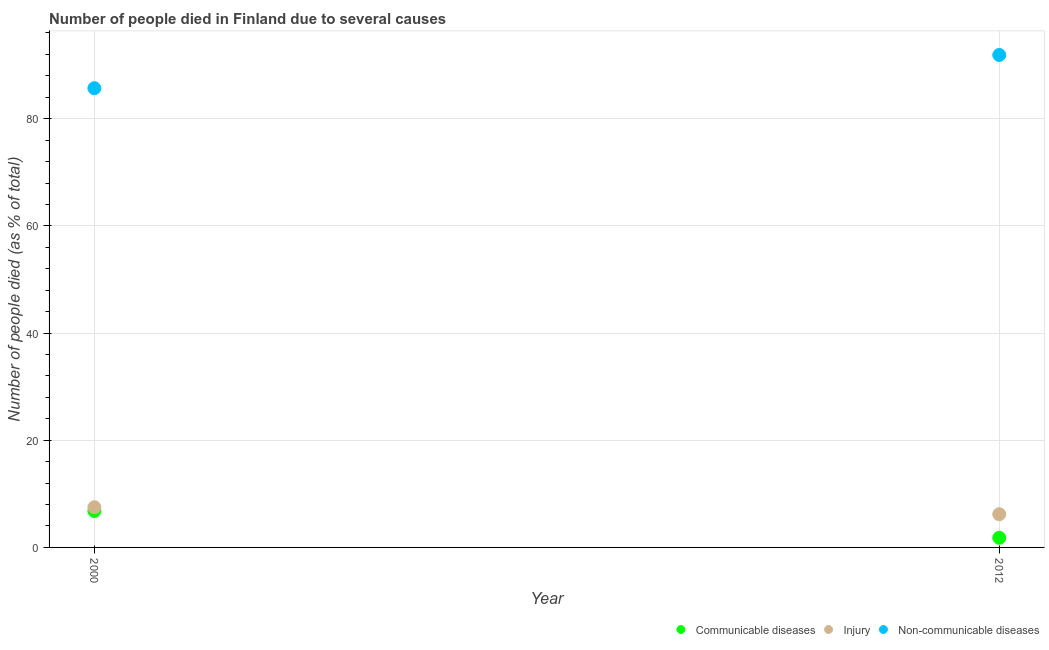How many different coloured dotlines are there?
Provide a short and direct response. 3. What is the number of people who dies of non-communicable diseases in 2000?
Provide a succinct answer. 85.7. Across all years, what is the maximum number of people who died of communicable diseases?
Your answer should be compact. 6.8. Across all years, what is the minimum number of people who dies of non-communicable diseases?
Ensure brevity in your answer.  85.7. In which year was the number of people who dies of non-communicable diseases maximum?
Give a very brief answer. 2012. In which year was the number of people who died of injury minimum?
Provide a short and direct response. 2012. What is the total number of people who dies of non-communicable diseases in the graph?
Offer a very short reply. 177.6. What is the difference between the number of people who dies of non-communicable diseases in 2012 and the number of people who died of communicable diseases in 2000?
Ensure brevity in your answer.  85.1. What is the average number of people who died of injury per year?
Offer a terse response. 6.85. In the year 2000, what is the difference between the number of people who died of communicable diseases and number of people who died of injury?
Your answer should be compact. -0.7. In how many years, is the number of people who died of injury greater than 28 %?
Your answer should be very brief. 0. What is the ratio of the number of people who died of injury in 2000 to that in 2012?
Keep it short and to the point. 1.21. Is the number of people who died of injury strictly greater than the number of people who dies of non-communicable diseases over the years?
Provide a succinct answer. No. Is the number of people who died of communicable diseases strictly less than the number of people who died of injury over the years?
Keep it short and to the point. Yes. How many dotlines are there?
Your response must be concise. 3. How many years are there in the graph?
Offer a very short reply. 2. Where does the legend appear in the graph?
Make the answer very short. Bottom right. How are the legend labels stacked?
Make the answer very short. Horizontal. What is the title of the graph?
Your answer should be very brief. Number of people died in Finland due to several causes. Does "Manufactures" appear as one of the legend labels in the graph?
Offer a very short reply. No. What is the label or title of the Y-axis?
Your answer should be compact. Number of people died (as % of total). What is the Number of people died (as % of total) of Communicable diseases in 2000?
Your answer should be compact. 6.8. What is the Number of people died (as % of total) of Non-communicable diseases in 2000?
Offer a terse response. 85.7. What is the Number of people died (as % of total) in Injury in 2012?
Offer a terse response. 6.2. What is the Number of people died (as % of total) in Non-communicable diseases in 2012?
Offer a terse response. 91.9. Across all years, what is the maximum Number of people died (as % of total) of Communicable diseases?
Offer a very short reply. 6.8. Across all years, what is the maximum Number of people died (as % of total) in Non-communicable diseases?
Your answer should be compact. 91.9. Across all years, what is the minimum Number of people died (as % of total) of Injury?
Your answer should be very brief. 6.2. Across all years, what is the minimum Number of people died (as % of total) of Non-communicable diseases?
Offer a terse response. 85.7. What is the total Number of people died (as % of total) in Non-communicable diseases in the graph?
Offer a very short reply. 177.6. What is the difference between the Number of people died (as % of total) in Communicable diseases in 2000 and that in 2012?
Offer a very short reply. 5. What is the difference between the Number of people died (as % of total) in Non-communicable diseases in 2000 and that in 2012?
Provide a succinct answer. -6.2. What is the difference between the Number of people died (as % of total) in Communicable diseases in 2000 and the Number of people died (as % of total) in Injury in 2012?
Offer a very short reply. 0.6. What is the difference between the Number of people died (as % of total) in Communicable diseases in 2000 and the Number of people died (as % of total) in Non-communicable diseases in 2012?
Keep it short and to the point. -85.1. What is the difference between the Number of people died (as % of total) in Injury in 2000 and the Number of people died (as % of total) in Non-communicable diseases in 2012?
Ensure brevity in your answer.  -84.4. What is the average Number of people died (as % of total) in Injury per year?
Ensure brevity in your answer.  6.85. What is the average Number of people died (as % of total) of Non-communicable diseases per year?
Your answer should be compact. 88.8. In the year 2000, what is the difference between the Number of people died (as % of total) of Communicable diseases and Number of people died (as % of total) of Injury?
Make the answer very short. -0.7. In the year 2000, what is the difference between the Number of people died (as % of total) of Communicable diseases and Number of people died (as % of total) of Non-communicable diseases?
Ensure brevity in your answer.  -78.9. In the year 2000, what is the difference between the Number of people died (as % of total) of Injury and Number of people died (as % of total) of Non-communicable diseases?
Make the answer very short. -78.2. In the year 2012, what is the difference between the Number of people died (as % of total) in Communicable diseases and Number of people died (as % of total) in Non-communicable diseases?
Provide a short and direct response. -90.1. In the year 2012, what is the difference between the Number of people died (as % of total) of Injury and Number of people died (as % of total) of Non-communicable diseases?
Offer a terse response. -85.7. What is the ratio of the Number of people died (as % of total) of Communicable diseases in 2000 to that in 2012?
Your answer should be compact. 3.78. What is the ratio of the Number of people died (as % of total) in Injury in 2000 to that in 2012?
Ensure brevity in your answer.  1.21. What is the ratio of the Number of people died (as % of total) in Non-communicable diseases in 2000 to that in 2012?
Give a very brief answer. 0.93. What is the difference between the highest and the second highest Number of people died (as % of total) of Communicable diseases?
Offer a terse response. 5. What is the difference between the highest and the second highest Number of people died (as % of total) in Non-communicable diseases?
Your response must be concise. 6.2. What is the difference between the highest and the lowest Number of people died (as % of total) of Communicable diseases?
Provide a succinct answer. 5. What is the difference between the highest and the lowest Number of people died (as % of total) in Injury?
Offer a very short reply. 1.3. What is the difference between the highest and the lowest Number of people died (as % of total) of Non-communicable diseases?
Your answer should be compact. 6.2. 